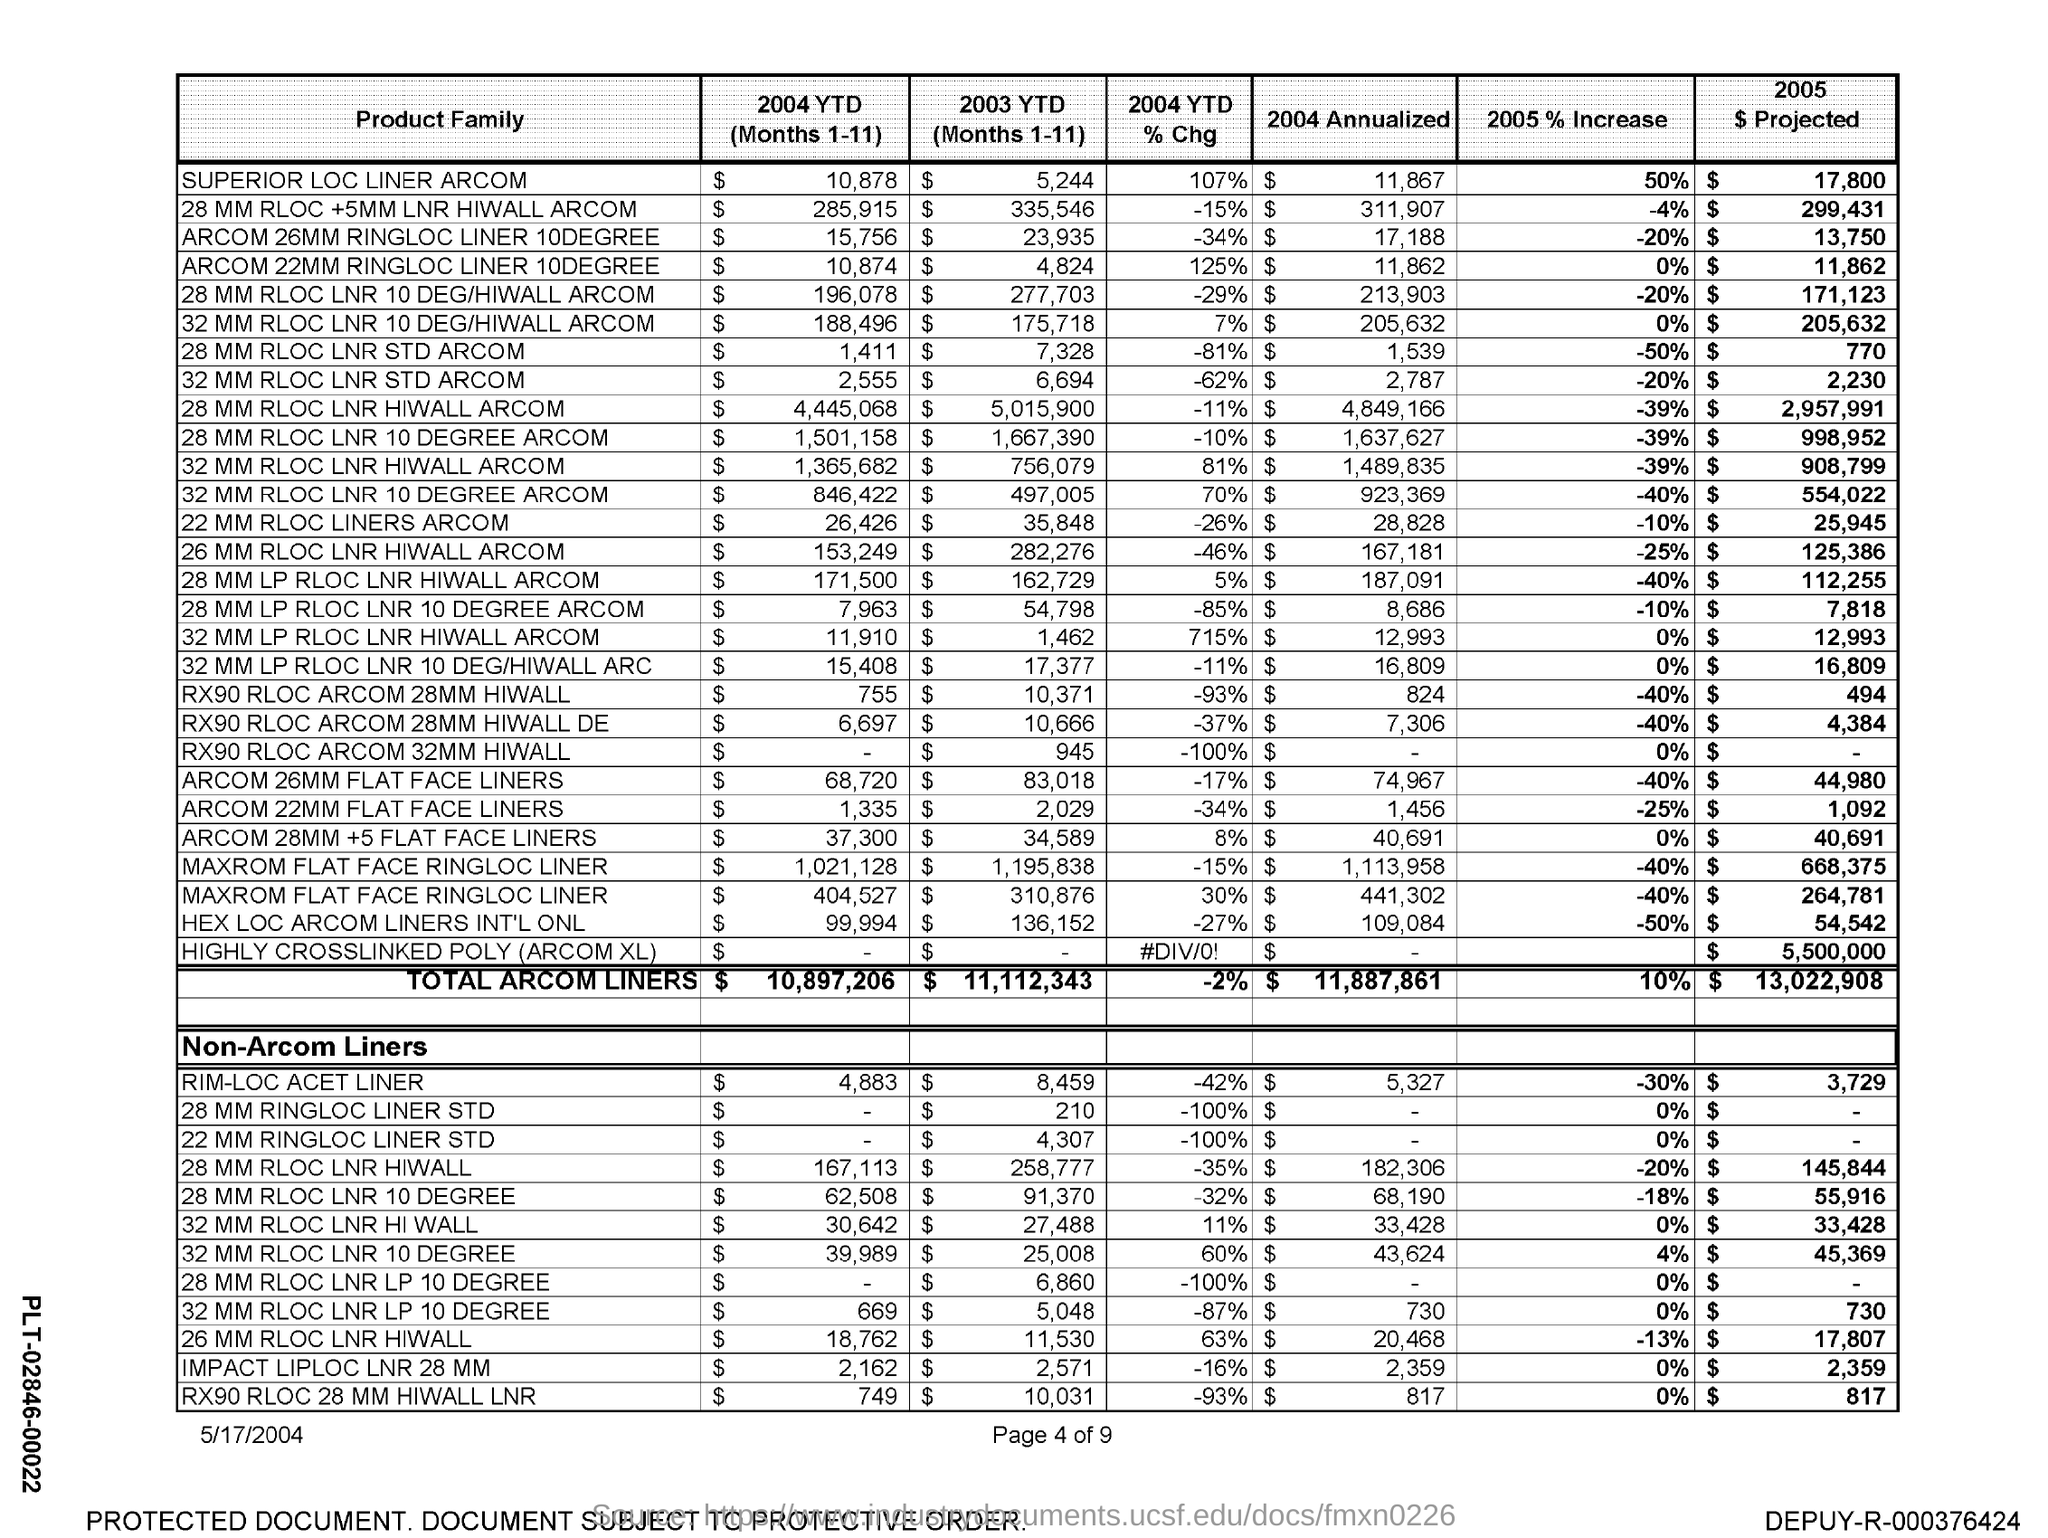Outline some significant characteristics in this image. As of the current year-to-date period, the percentage change for Superior LOC Liner ARCOM is 107%. The total ARCOM Liners for 2003 YTD (January to November) is $11,112,343. The total ARCOM Liners for the year 2004 up to Month 11 (1-11) is $10,897,206. The total annualized ARCOM Liners for 2004 was $11,887,861. For the period from January to November 2004, the total amount of Superior LOC Liner ARCOM was $10,878. 